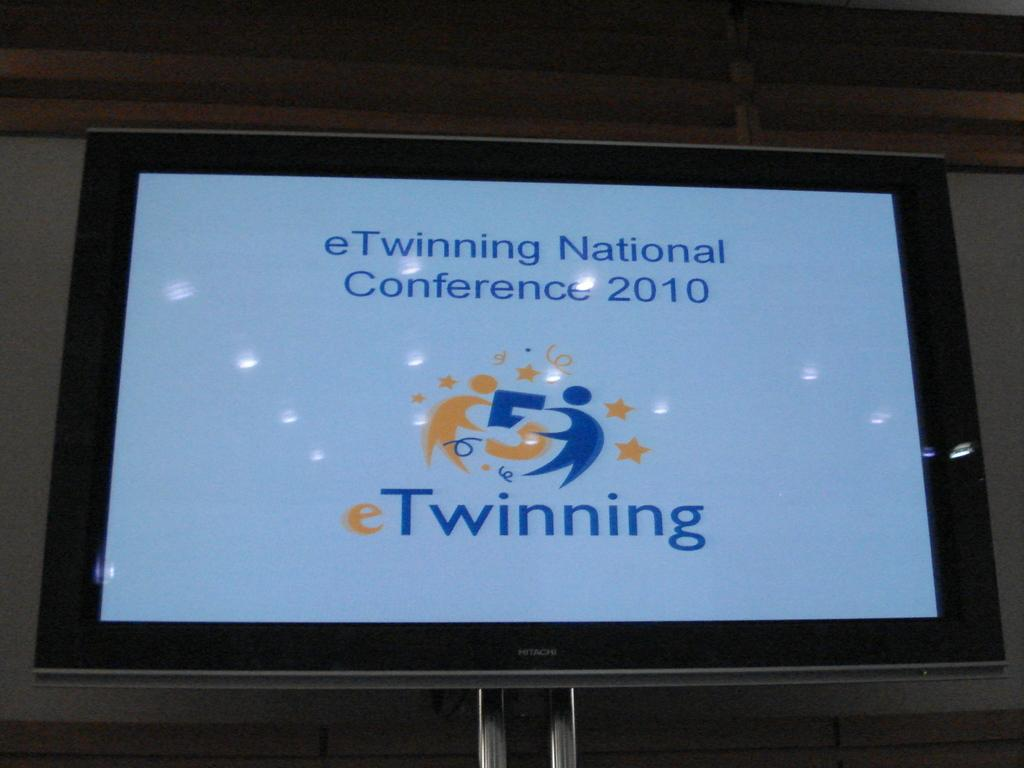Provide a one-sentence caption for the provided image. A blue screen with the word Twinning surrounded by a black frame. 